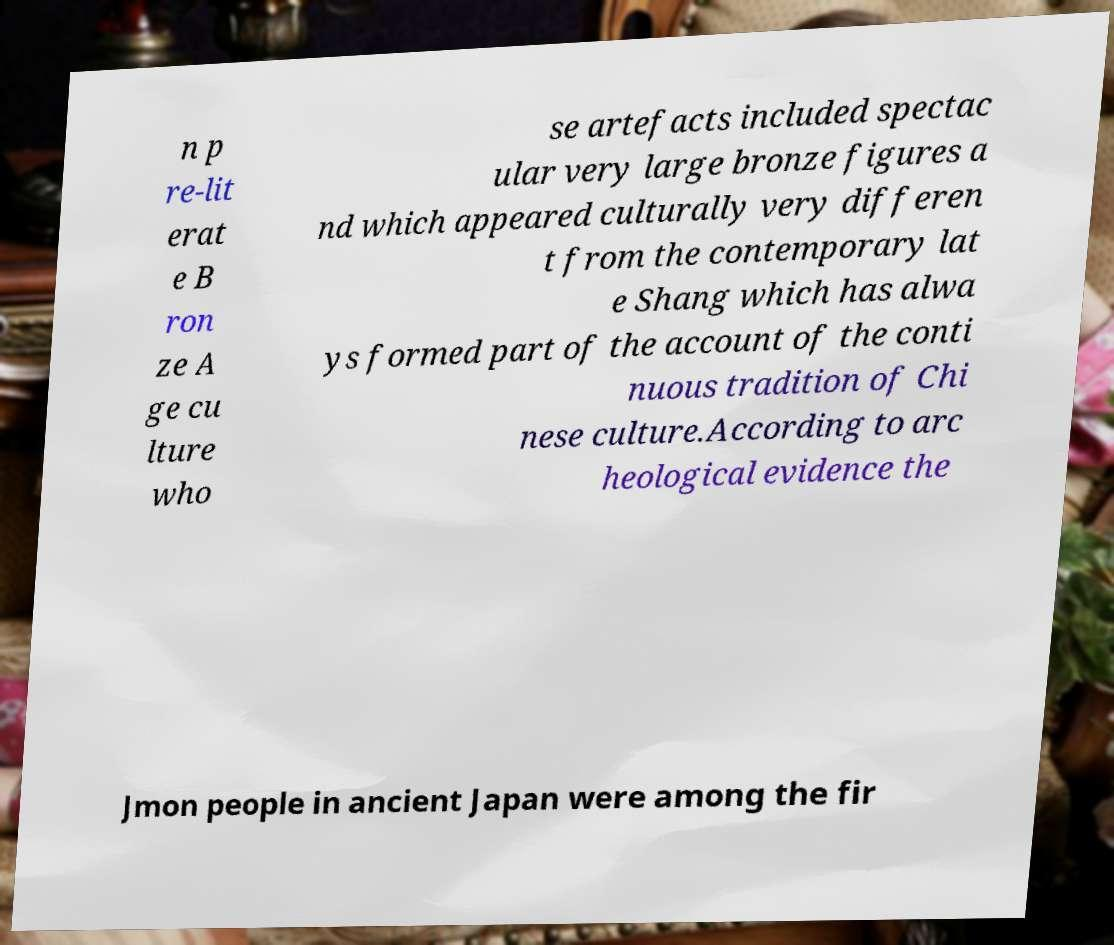Can you read and provide the text displayed in the image?This photo seems to have some interesting text. Can you extract and type it out for me? n p re-lit erat e B ron ze A ge cu lture who se artefacts included spectac ular very large bronze figures a nd which appeared culturally very differen t from the contemporary lat e Shang which has alwa ys formed part of the account of the conti nuous tradition of Chi nese culture.According to arc heological evidence the Jmon people in ancient Japan were among the fir 